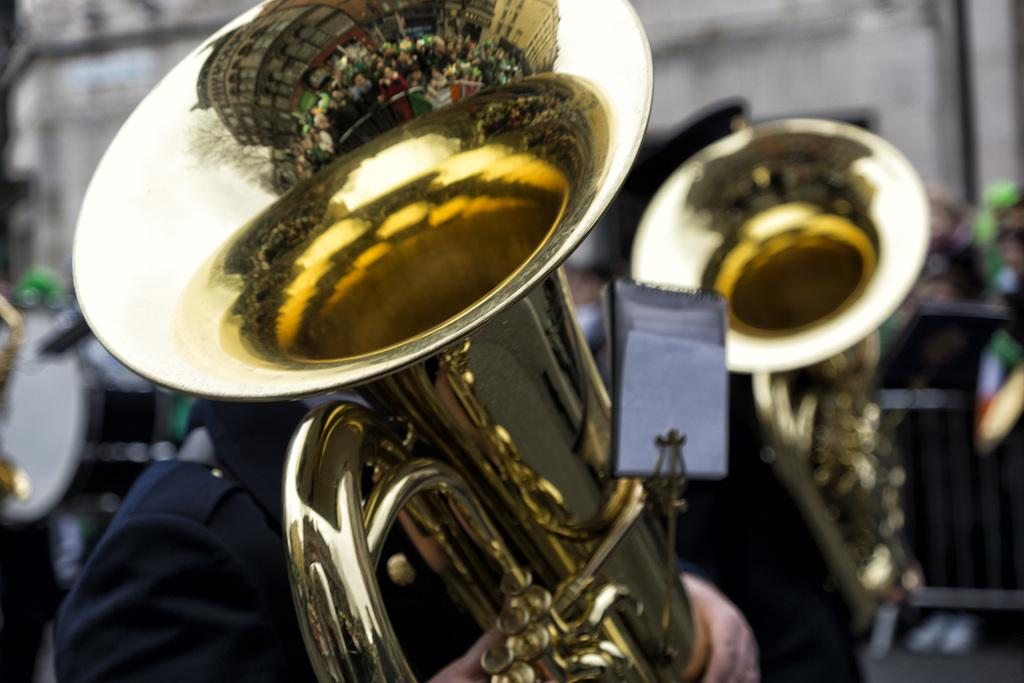What musical instruments are present in the image? There are saxophones in the image. What can be seen in the background of the image? There are people, a musical drum, a fence, a wall, a pipe, and some unspecified objects in the background of the image. Can you describe the quality of the image? The image is blurry. What type of berry is growing on the wall in the image? There are no berries present in the image; the wall is part of the background and does not have any berries growing on it. 